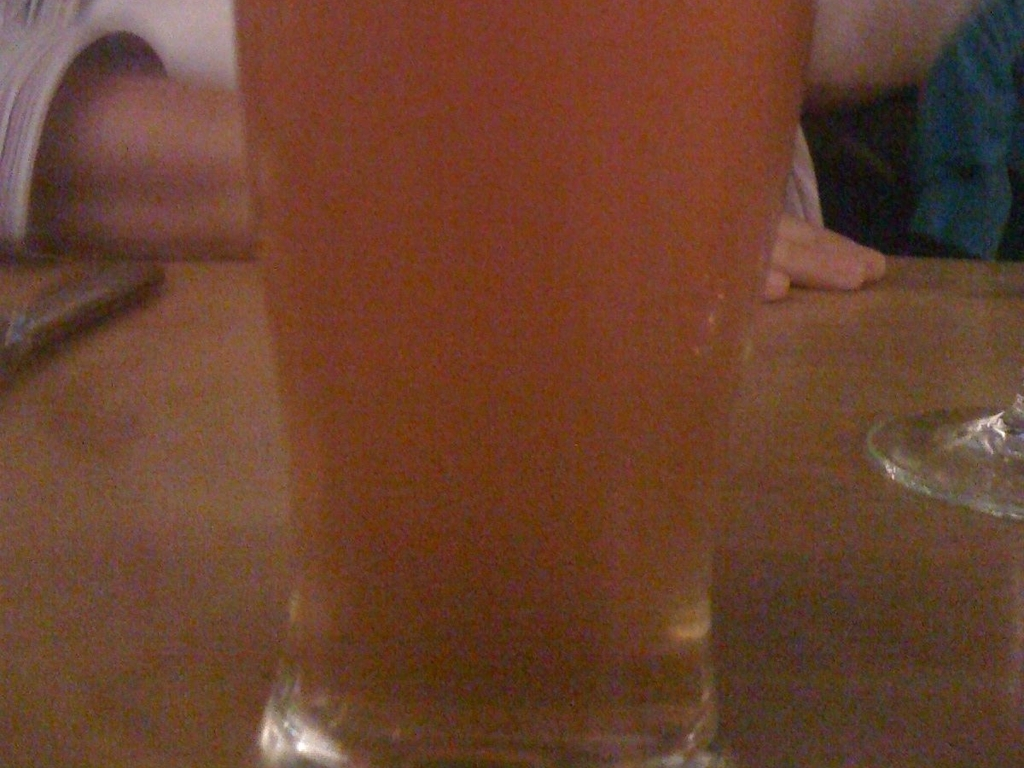Can you describe the setting in which this glass is placed based on the background? The image lacks detail, but the presence of what could be interpreted as a table edge and the proximity to other potential patrons or objects suggest the glass could be on a bar or a table in a social setting. 